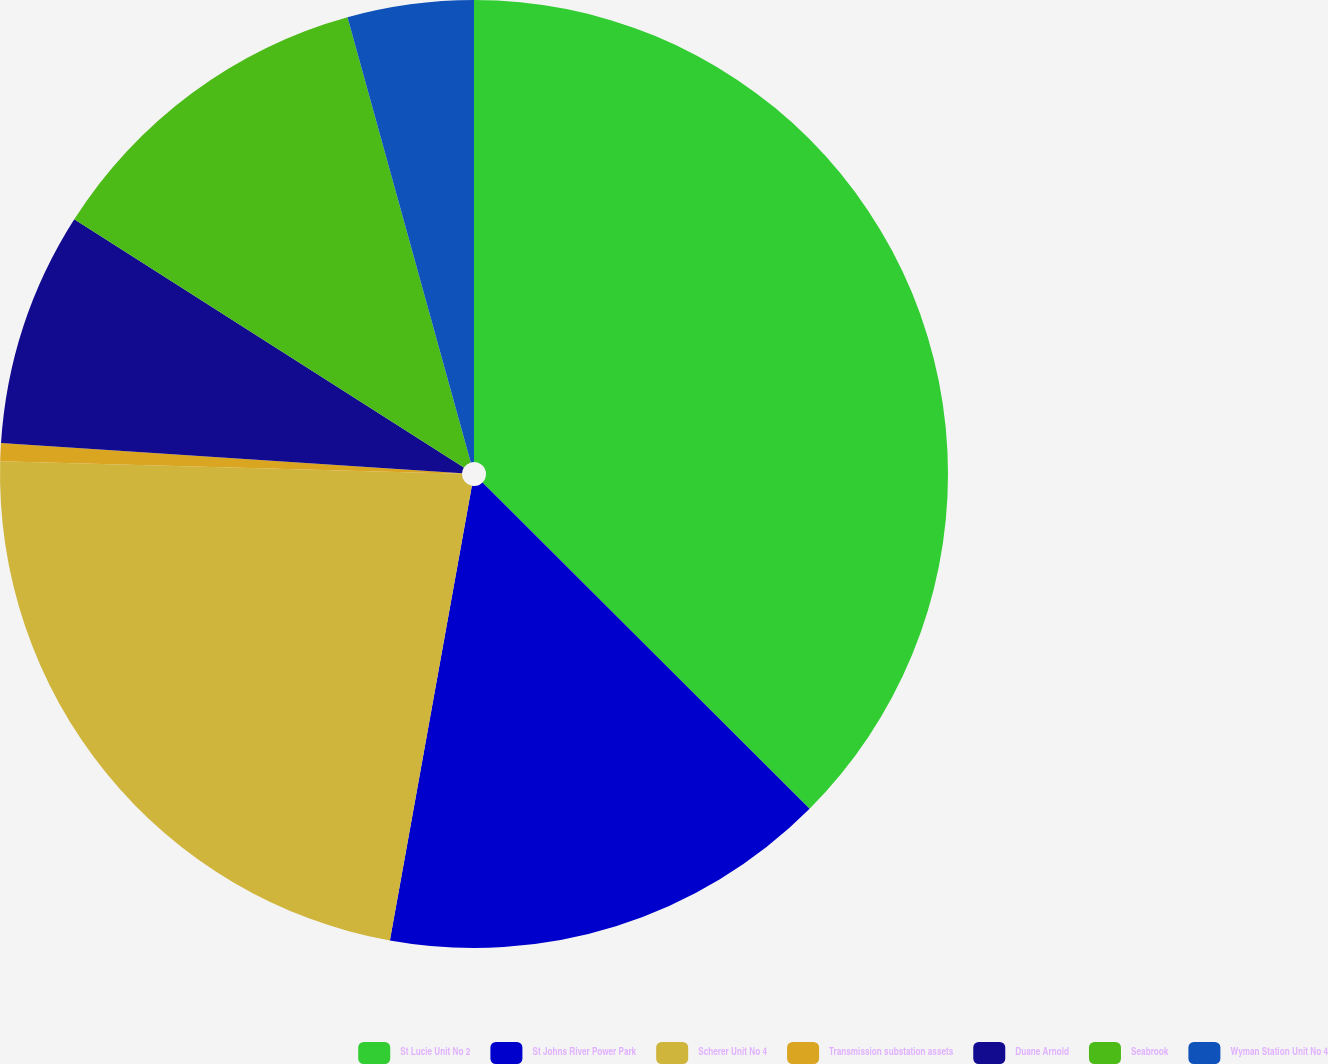Convert chart. <chart><loc_0><loc_0><loc_500><loc_500><pie_chart><fcel>St Lucie Unit No 2<fcel>St Johns River Power Park<fcel>Scherer Unit No 4<fcel>Transmission substation assets<fcel>Duane Arnold<fcel>Seabrook<fcel>Wyman Station Unit No 4<nl><fcel>37.48%<fcel>15.36%<fcel>22.59%<fcel>0.61%<fcel>7.99%<fcel>11.67%<fcel>4.3%<nl></chart> 